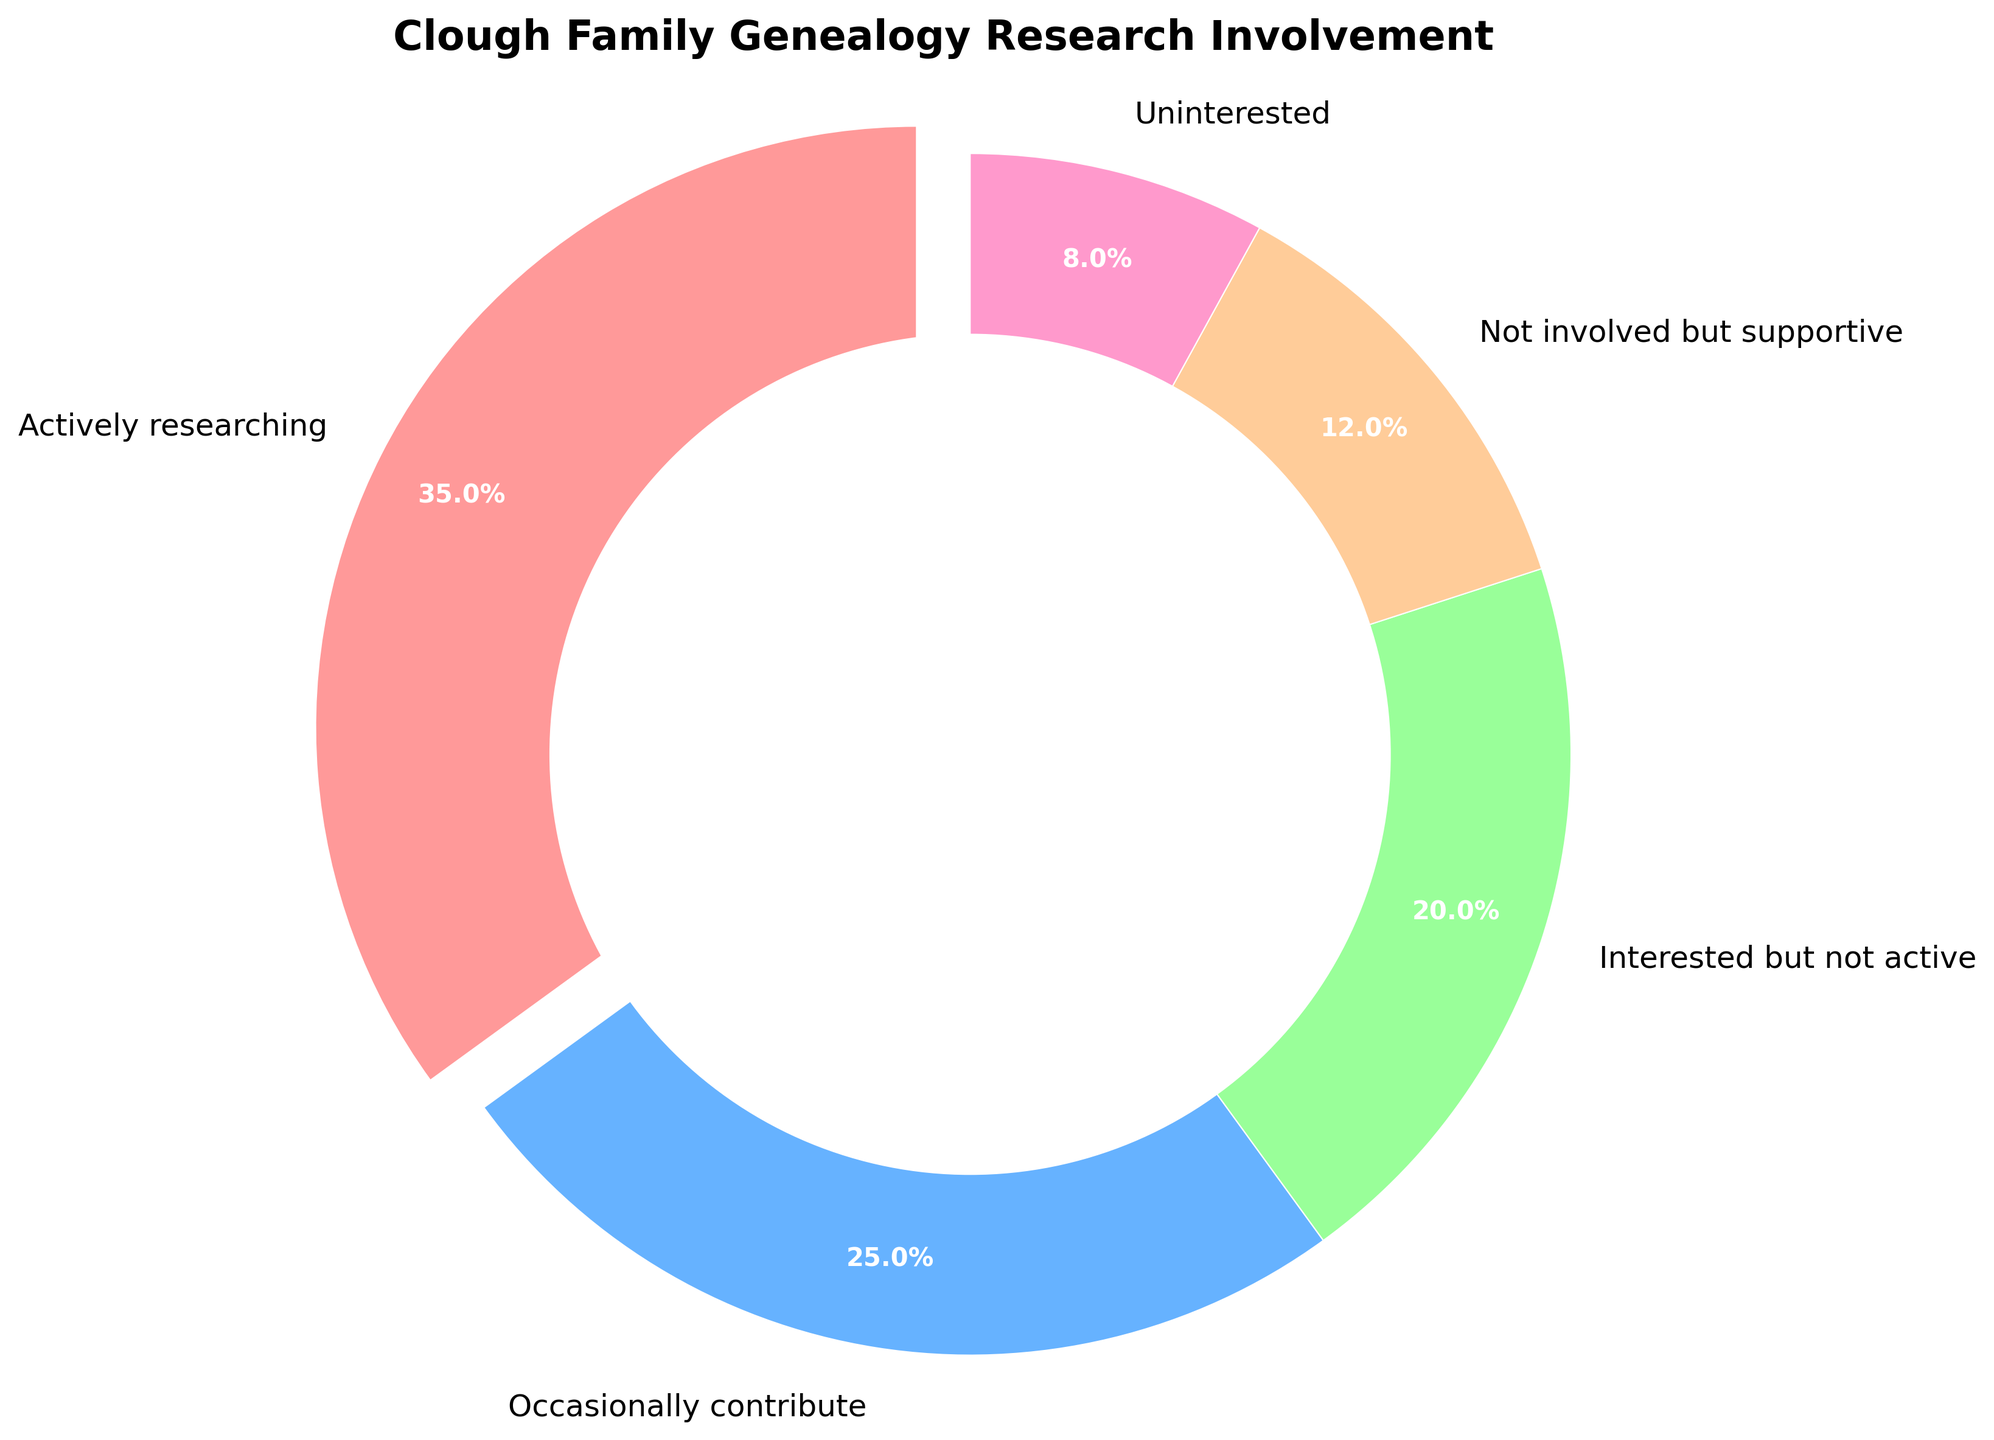What percentage of the Clough family is either actively researching or occasionally contributing to genealogy research? To find the percentage of family members who are either actively researching or occasionally contributing, add the percentages of these two groups: 35% for actively researching and 25% for occasionally contributing. Thus, 35% + 25% = 60%.
Answer: 60% Which involvement level represents the smallest portion of the Clough family? By looking at the pie chart, "Uninterested" has the smallest segment, representing 8% of the Clough family.
Answer: Uninterested How much more percentage is actively researching compared to those uninterested in genealogy research? Subtract the percentage of uninterested family members from those actively researching: 35% (actively researching) - 8% (uninterested) = 27%.
Answer: 27% Which segment is larger: those occasionally contributing or those interested but not active? Compare the two values: 25% for those occasionally contributing and 20% for those interested but not active. 25% is larger than 20%.
Answer: Occasionally contributing Approximately what fraction of the pie chart does the "Not involved but supportive" segment cover? The "Not involved but supportive" segment is 12%. Considering the whole pie chart represents 100%, 12% is roughly equivalent to 12/100, which simplifies to approximately 1/8.
Answer: 1/8 What is the combined percentage of family members who are either not involved but supportive or uninterested? To find the combined percentage of these two groups, add their percentages: 12% + 8% = 20%.
Answer: 20% Is there a larger segment of the pie chart for those interested but not active than for those uninterested? By comparing, the "Interested but not active" segment is 20%, while the "Uninterested" segment is 8%. 20% is larger than 8%.
Answer: Yes What color represents the "Actively researching" segment in the pie chart? The segment for "Actively researching" is highlighted and is in the red color.
Answer: Red How many levels of involvement are represented in the pie chart? Count the distinct segments in the pie chart, which shows 5 different categories of involvement.
Answer: 5 